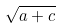Convert formula to latex. <formula><loc_0><loc_0><loc_500><loc_500>\sqrt { a + c }</formula> 